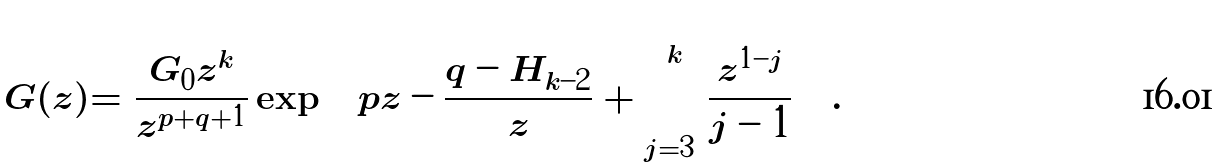Convert formula to latex. <formula><loc_0><loc_0><loc_500><loc_500>G ( z ) = \frac { G _ { 0 } z ^ { k } } { z ^ { p + q + 1 } } \exp \left ( p z - \frac { q - H _ { k - 2 } } { z } + \sum _ { j = 3 } ^ { k } \frac { z ^ { 1 - j } } { j - 1 } \right ) .</formula> 